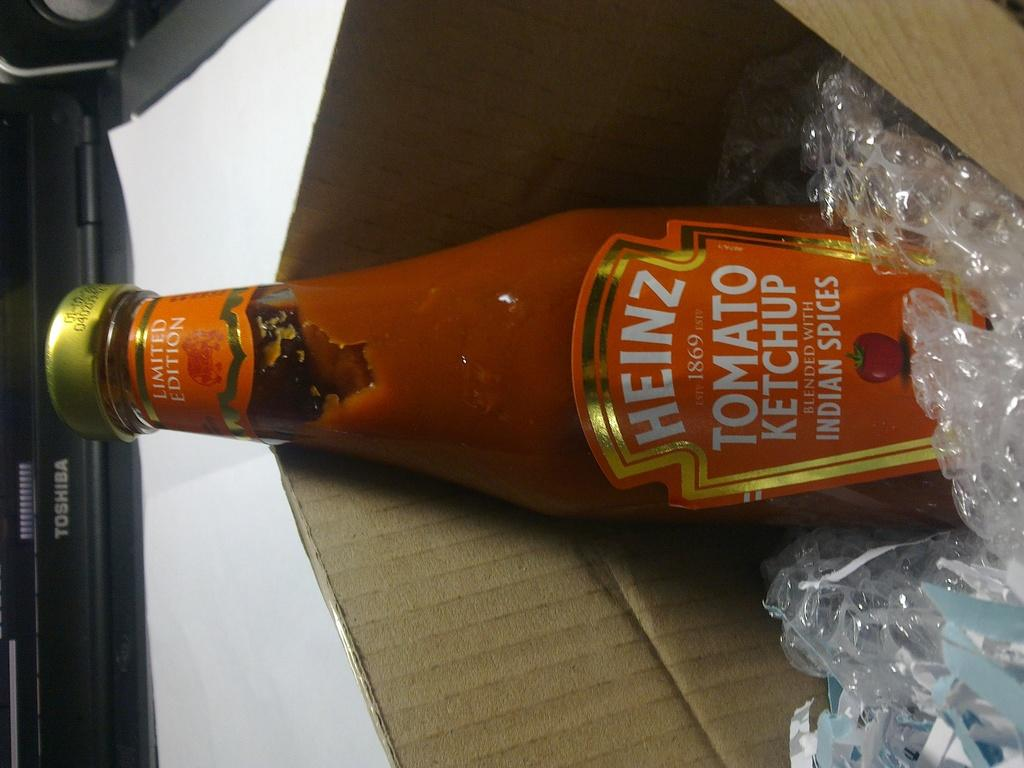Provide a one-sentence caption for the provided image. An open box with a bottle of Heinz tomato ketchup. 